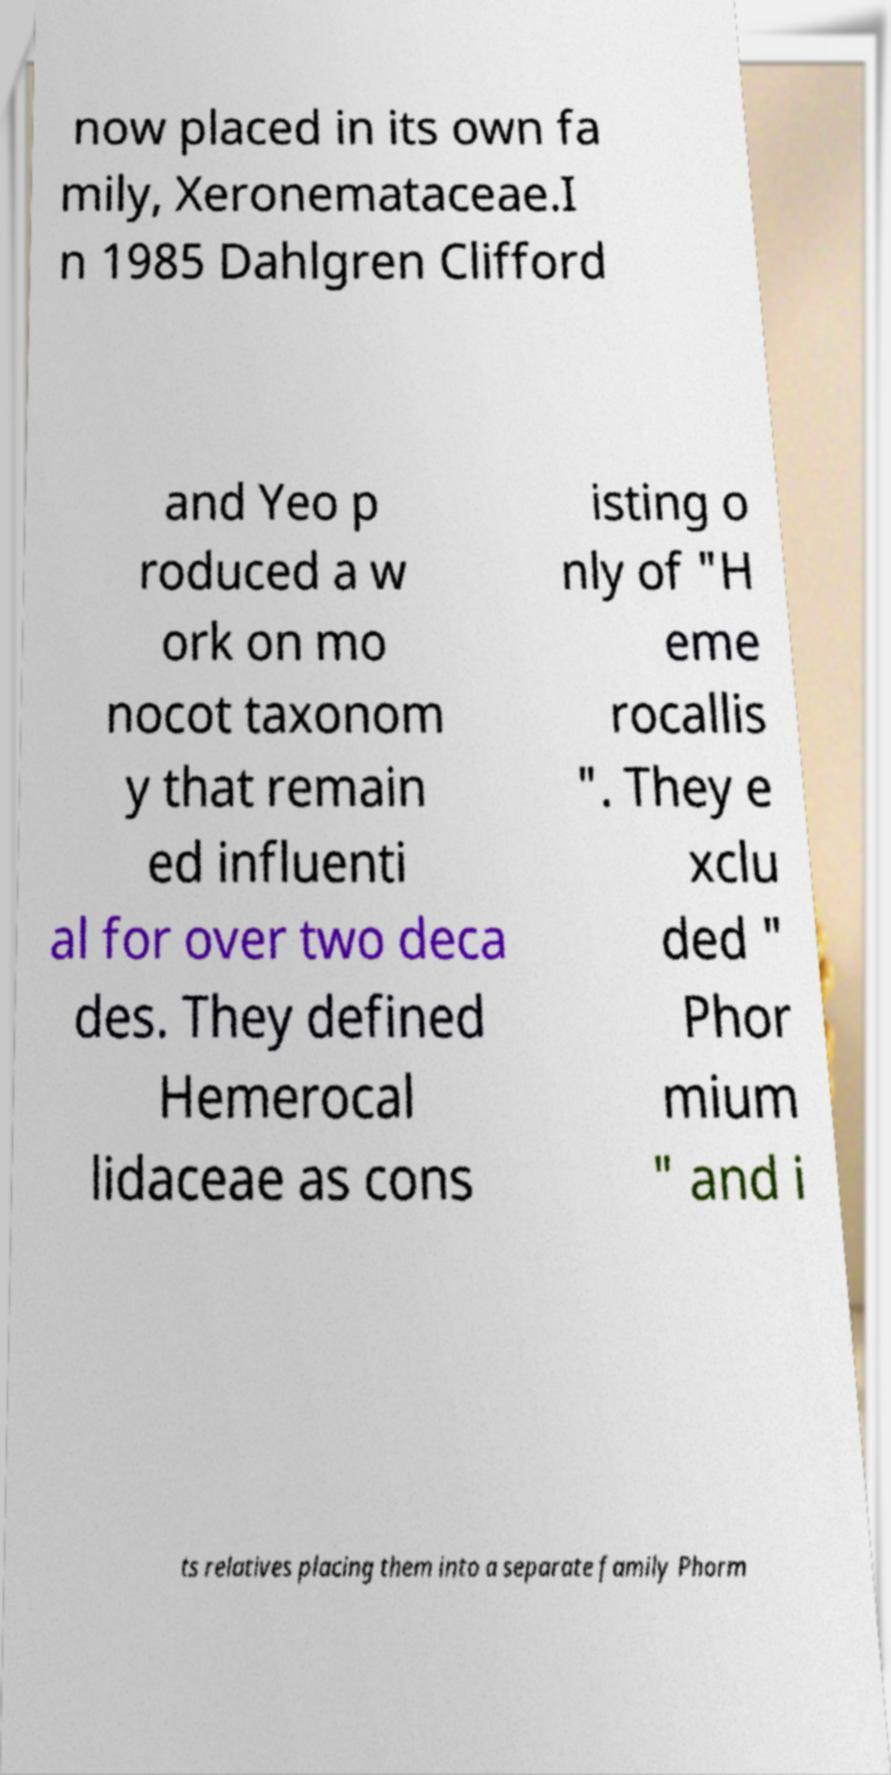Could you extract and type out the text from this image? now placed in its own fa mily, Xeronemataceae.I n 1985 Dahlgren Clifford and Yeo p roduced a w ork on mo nocot taxonom y that remain ed influenti al for over two deca des. They defined Hemerocal lidaceae as cons isting o nly of "H eme rocallis ". They e xclu ded " Phor mium " and i ts relatives placing them into a separate family Phorm 